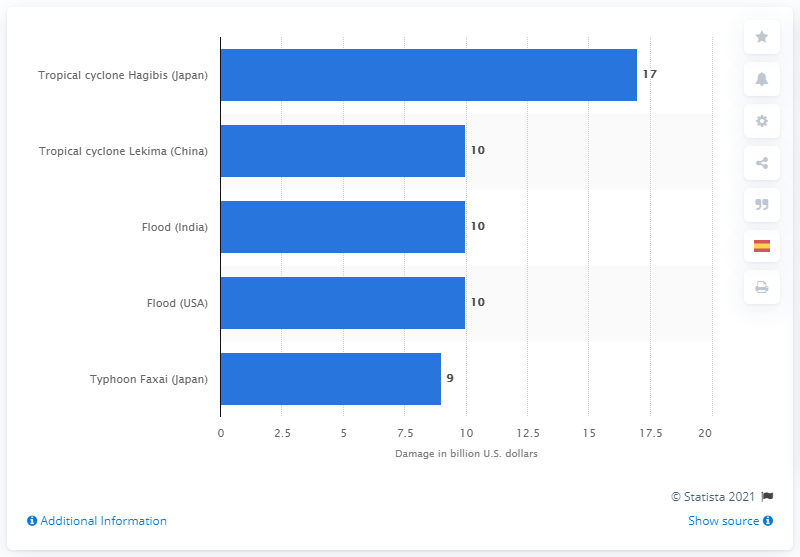Highlight a few significant elements in this photo. The financial impact of Tropical Cyclone Hagibis was significant, with estimates indicating that the storm caused X amount of money in damages. 